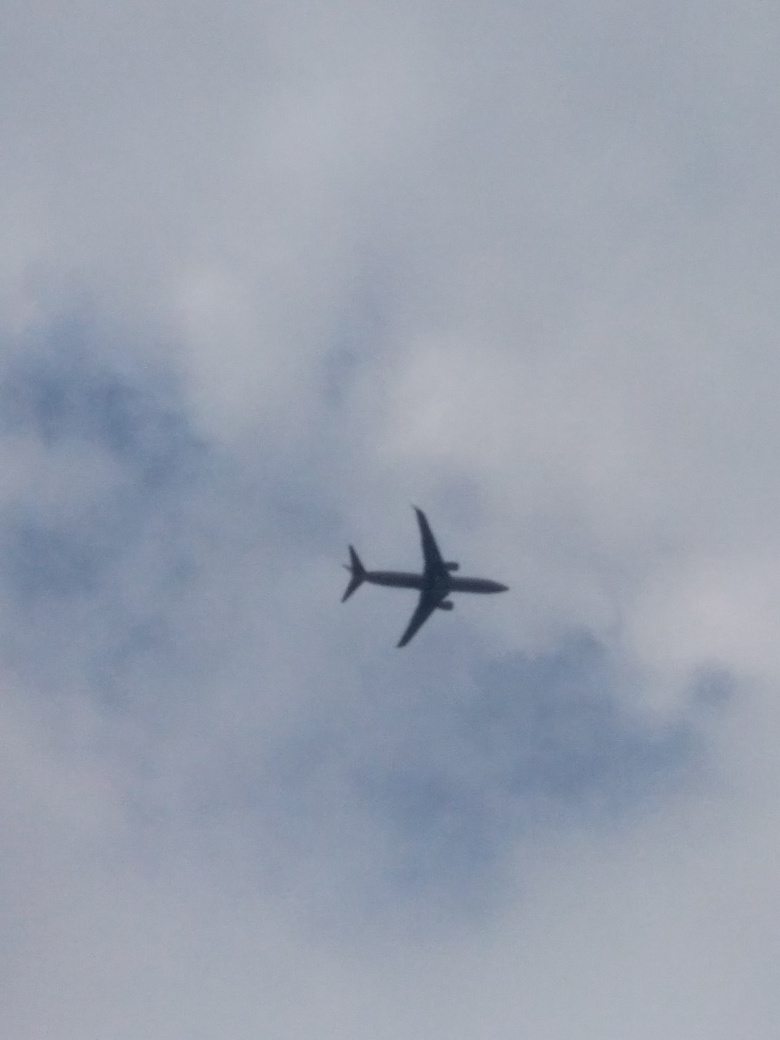Can you comment on the dynamics of the airplane captured in this image? Certainly. The airplane is captured mid-flight with its wings level, suggesting stable flight conditions. The angle and elevation imply it may be at cruising altitude, or possibly ascending or descending, depending on its distance from the viewer. The image provides a snapshot of modern air travel and its intersection with varying weather patterns. What could the airplane's presence indicate about human activities or the time of day? The airplane's presence could suggest several aspects of human activity, such as the importance of air travel in connecting different regions. Depending on the context, it could be indicative of a busy flight corridor. If one were to speculate about the time of day, given the lighting, it may be during hours when flights are often scheduled, either in the morning or late afternoon. However, without more contextual information, it is difficult to ascertain the exact time. 